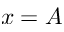Convert formula to latex. <formula><loc_0><loc_0><loc_500><loc_500>x = A</formula> 